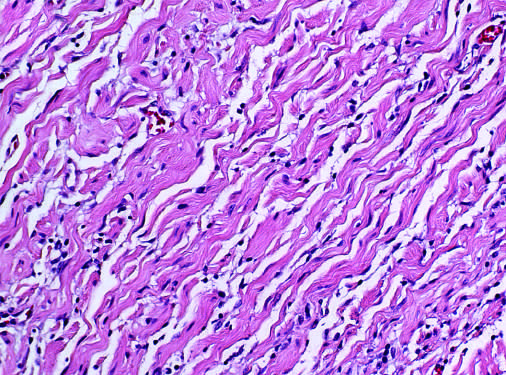what is wavy collagen bundles likened to?
Answer the question using a single word or phrase. Carrot shavings 